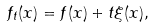<formula> <loc_0><loc_0><loc_500><loc_500>f _ { t } ( x ) = f ( x ) + t \xi ( x ) ,</formula> 